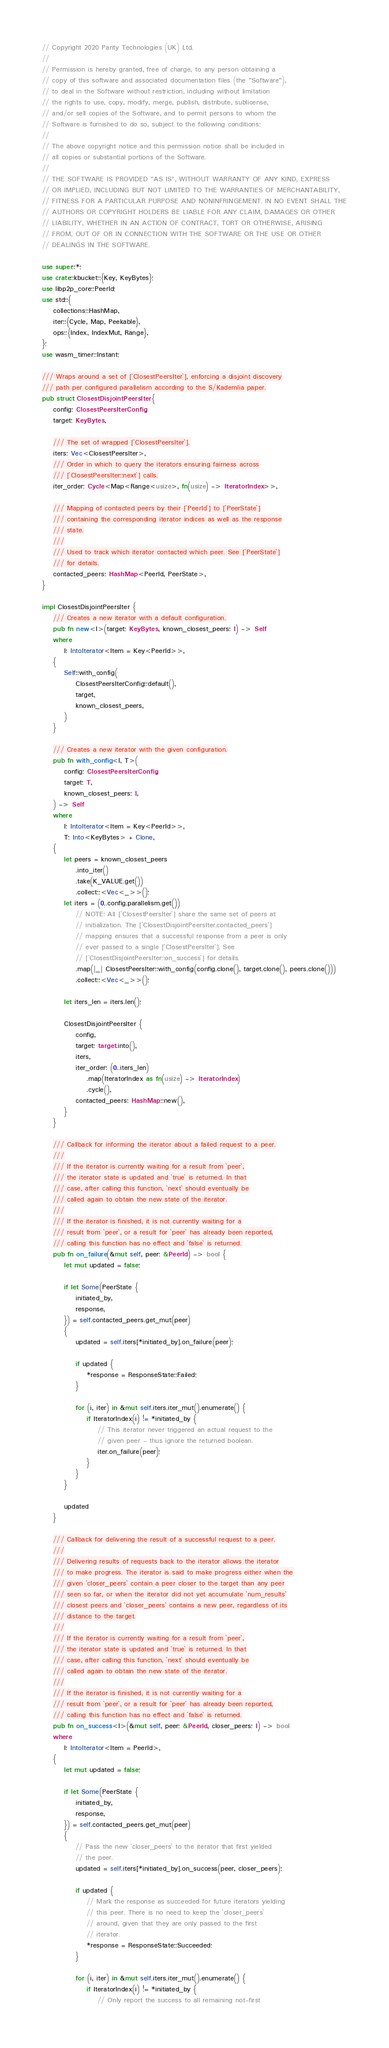<code> <loc_0><loc_0><loc_500><loc_500><_Rust_>// Copyright 2020 Parity Technologies (UK) Ltd.
//
// Permission is hereby granted, free of charge, to any person obtaining a
// copy of this software and associated documentation files (the "Software"),
// to deal in the Software without restriction, including without limitation
// the rights to use, copy, modify, merge, publish, distribute, sublicense,
// and/or sell copies of the Software, and to permit persons to whom the
// Software is furnished to do so, subject to the following conditions:
//
// The above copyright notice and this permission notice shall be included in
// all copies or substantial portions of the Software.
//
// THE SOFTWARE IS PROVIDED "AS IS", WITHOUT WARRANTY OF ANY KIND, EXPRESS
// OR IMPLIED, INCLUDING BUT NOT LIMITED TO THE WARRANTIES OF MERCHANTABILITY,
// FITNESS FOR A PARTICULAR PURPOSE AND NONINFRINGEMENT. IN NO EVENT SHALL THE
// AUTHORS OR COPYRIGHT HOLDERS BE LIABLE FOR ANY CLAIM, DAMAGES OR OTHER
// LIABILITY, WHETHER IN AN ACTION OF CONTRACT, TORT OR OTHERWISE, ARISING
// FROM, OUT OF OR IN CONNECTION WITH THE SOFTWARE OR THE USE OR OTHER
// DEALINGS IN THE SOFTWARE.

use super::*;
use crate::kbucket::{Key, KeyBytes};
use libp2p_core::PeerId;
use std::{
    collections::HashMap,
    iter::{Cycle, Map, Peekable},
    ops::{Index, IndexMut, Range},
};
use wasm_timer::Instant;

/// Wraps around a set of [`ClosestPeersIter`], enforcing a disjoint discovery
/// path per configured parallelism according to the S/Kademlia paper.
pub struct ClosestDisjointPeersIter {
    config: ClosestPeersIterConfig,
    target: KeyBytes,

    /// The set of wrapped [`ClosestPeersIter`].
    iters: Vec<ClosestPeersIter>,
    /// Order in which to query the iterators ensuring fairness across
    /// [`ClosestPeersIter::next`] calls.
    iter_order: Cycle<Map<Range<usize>, fn(usize) -> IteratorIndex>>,

    /// Mapping of contacted peers by their [`PeerId`] to [`PeerState`]
    /// containing the corresponding iterator indices as well as the response
    /// state.
    ///
    /// Used to track which iterator contacted which peer. See [`PeerState`]
    /// for details.
    contacted_peers: HashMap<PeerId, PeerState>,
}

impl ClosestDisjointPeersIter {
    /// Creates a new iterator with a default configuration.
    pub fn new<I>(target: KeyBytes, known_closest_peers: I) -> Self
    where
        I: IntoIterator<Item = Key<PeerId>>,
    {
        Self::with_config(
            ClosestPeersIterConfig::default(),
            target,
            known_closest_peers,
        )
    }

    /// Creates a new iterator with the given configuration.
    pub fn with_config<I, T>(
        config: ClosestPeersIterConfig,
        target: T,
        known_closest_peers: I,
    ) -> Self
    where
        I: IntoIterator<Item = Key<PeerId>>,
        T: Into<KeyBytes> + Clone,
    {
        let peers = known_closest_peers
            .into_iter()
            .take(K_VALUE.get())
            .collect::<Vec<_>>();
        let iters = (0..config.parallelism.get())
            // NOTE: All [`ClosestPeersIter`] share the same set of peers at
            // initialization. The [`ClosestDisjointPeersIter.contacted_peers`]
            // mapping ensures that a successful response from a peer is only
            // ever passed to a single [`ClosestPeersIter`]. See
            // [`ClosestDisjointPeersIter::on_success`] for details.
            .map(|_| ClosestPeersIter::with_config(config.clone(), target.clone(), peers.clone()))
            .collect::<Vec<_>>();

        let iters_len = iters.len();

        ClosestDisjointPeersIter {
            config,
            target: target.into(),
            iters,
            iter_order: (0..iters_len)
                .map(IteratorIndex as fn(usize) -> IteratorIndex)
                .cycle(),
            contacted_peers: HashMap::new(),
        }
    }

    /// Callback for informing the iterator about a failed request to a peer.
    ///
    /// If the iterator is currently waiting for a result from `peer`,
    /// the iterator state is updated and `true` is returned. In that
    /// case, after calling this function, `next` should eventually be
    /// called again to obtain the new state of the iterator.
    ///
    /// If the iterator is finished, it is not currently waiting for a
    /// result from `peer`, or a result for `peer` has already been reported,
    /// calling this function has no effect and `false` is returned.
    pub fn on_failure(&mut self, peer: &PeerId) -> bool {
        let mut updated = false;

        if let Some(PeerState {
            initiated_by,
            response,
        }) = self.contacted_peers.get_mut(peer)
        {
            updated = self.iters[*initiated_by].on_failure(peer);

            if updated {
                *response = ResponseState::Failed;
            }

            for (i, iter) in &mut self.iters.iter_mut().enumerate() {
                if IteratorIndex(i) != *initiated_by {
                    // This iterator never triggered an actual request to the
                    // given peer - thus ignore the returned boolean.
                    iter.on_failure(peer);
                }
            }
        }

        updated
    }

    /// Callback for delivering the result of a successful request to a peer.
    ///
    /// Delivering results of requests back to the iterator allows the iterator
    /// to make progress. The iterator is said to make progress either when the
    /// given `closer_peers` contain a peer closer to the target than any peer
    /// seen so far, or when the iterator did not yet accumulate `num_results`
    /// closest peers and `closer_peers` contains a new peer, regardless of its
    /// distance to the target.
    ///
    /// If the iterator is currently waiting for a result from `peer`,
    /// the iterator state is updated and `true` is returned. In that
    /// case, after calling this function, `next` should eventually be
    /// called again to obtain the new state of the iterator.
    ///
    /// If the iterator is finished, it is not currently waiting for a
    /// result from `peer`, or a result for `peer` has already been reported,
    /// calling this function has no effect and `false` is returned.
    pub fn on_success<I>(&mut self, peer: &PeerId, closer_peers: I) -> bool
    where
        I: IntoIterator<Item = PeerId>,
    {
        let mut updated = false;

        if let Some(PeerState {
            initiated_by,
            response,
        }) = self.contacted_peers.get_mut(peer)
        {
            // Pass the new `closer_peers` to the iterator that first yielded
            // the peer.
            updated = self.iters[*initiated_by].on_success(peer, closer_peers);

            if updated {
                // Mark the response as succeeded for future iterators yielding
                // this peer. There is no need to keep the `closer_peers`
                // around, given that they are only passed to the first
                // iterator.
                *response = ResponseState::Succeeded;
            }

            for (i, iter) in &mut self.iters.iter_mut().enumerate() {
                if IteratorIndex(i) != *initiated_by {
                    // Only report the success to all remaining not-first</code> 